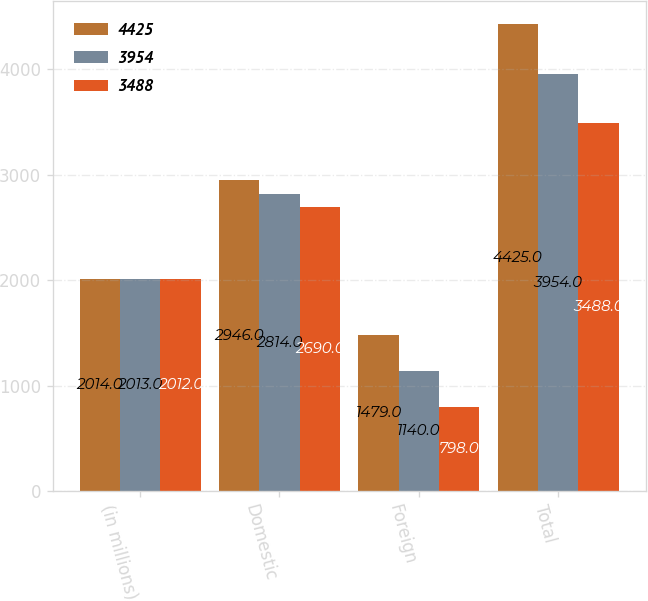Convert chart. <chart><loc_0><loc_0><loc_500><loc_500><stacked_bar_chart><ecel><fcel>(in millions)<fcel>Domestic<fcel>Foreign<fcel>Total<nl><fcel>4425<fcel>2014<fcel>2946<fcel>1479<fcel>4425<nl><fcel>3954<fcel>2013<fcel>2814<fcel>1140<fcel>3954<nl><fcel>3488<fcel>2012<fcel>2690<fcel>798<fcel>3488<nl></chart> 